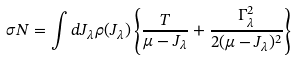Convert formula to latex. <formula><loc_0><loc_0><loc_500><loc_500>\sigma N = \int d J _ { \lambda } \rho ( J _ { \lambda } ) \left \{ \frac { T } { \mu - J _ { \lambda } } + \frac { \Gamma ^ { 2 } _ { \lambda } } { 2 ( \mu - J _ { \lambda } ) ^ { 2 } } \right \}</formula> 